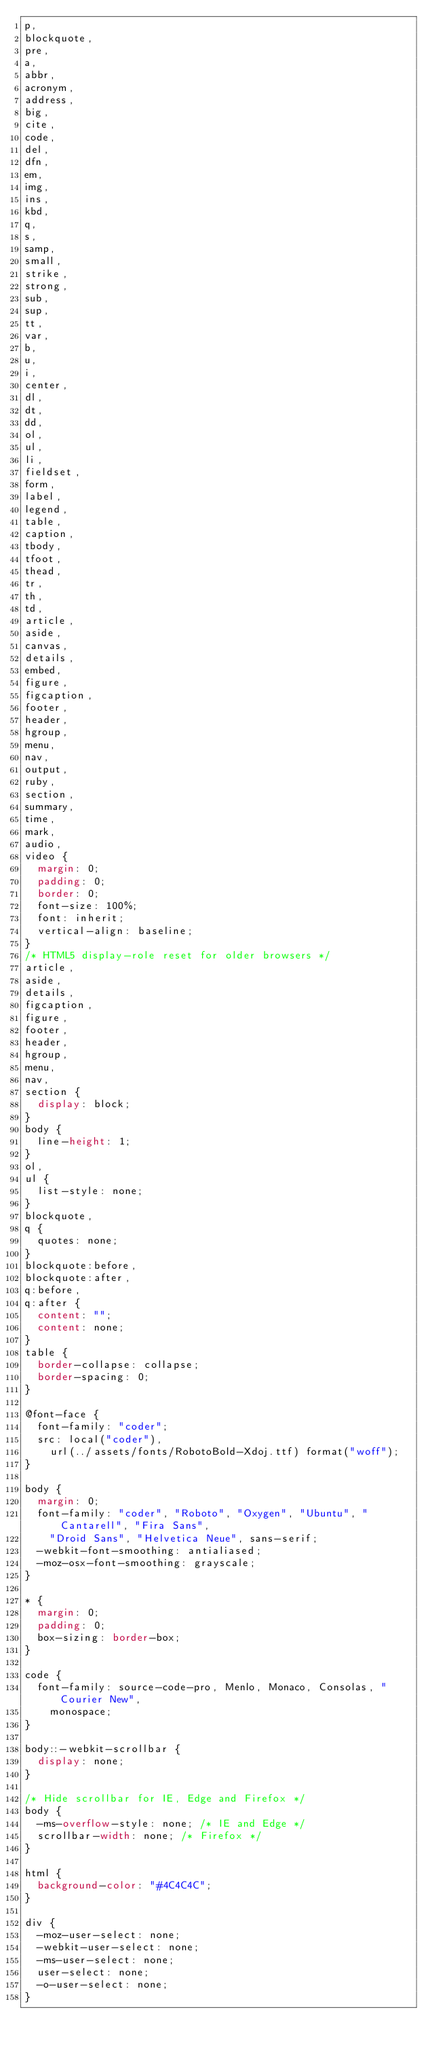<code> <loc_0><loc_0><loc_500><loc_500><_CSS_>p,
blockquote,
pre,
a,
abbr,
acronym,
address,
big,
cite,
code,
del,
dfn,
em,
img,
ins,
kbd,
q,
s,
samp,
small,
strike,
strong,
sub,
sup,
tt,
var,
b,
u,
i,
center,
dl,
dt,
dd,
ol,
ul,
li,
fieldset,
form,
label,
legend,
table,
caption,
tbody,
tfoot,
thead,
tr,
th,
td,
article,
aside,
canvas,
details,
embed,
figure,
figcaption,
footer,
header,
hgroup,
menu,
nav,
output,
ruby,
section,
summary,
time,
mark,
audio,
video {
  margin: 0;
  padding: 0;
  border: 0;
  font-size: 100%;
  font: inherit;
  vertical-align: baseline;
}
/* HTML5 display-role reset for older browsers */
article,
aside,
details,
figcaption,
figure,
footer,
header,
hgroup,
menu,
nav,
section {
  display: block;
}
body {
  line-height: 1;
}
ol,
ul {
  list-style: none;
}
blockquote,
q {
  quotes: none;
}
blockquote:before,
blockquote:after,
q:before,
q:after {
  content: "";
  content: none;
}
table {
  border-collapse: collapse;
  border-spacing: 0;
}

@font-face {
  font-family: "coder";
  src: local("coder"),
    url(../assets/fonts/RobotoBold-Xdoj.ttf) format("woff");
}

body {
  margin: 0;
  font-family: "coder", "Roboto", "Oxygen", "Ubuntu", "Cantarell", "Fira Sans",
    "Droid Sans", "Helvetica Neue", sans-serif;
  -webkit-font-smoothing: antialiased;
  -moz-osx-font-smoothing: grayscale;
}

* {
  margin: 0;
  padding: 0;
  box-sizing: border-box;
}

code {
  font-family: source-code-pro, Menlo, Monaco, Consolas, "Courier New",
    monospace;
}

body::-webkit-scrollbar {
  display: none;
}

/* Hide scrollbar for IE, Edge and Firefox */
body {
  -ms-overflow-style: none; /* IE and Edge */
  scrollbar-width: none; /* Firefox */
}

html {
  background-color: "#4C4C4C";
}

div {
  -moz-user-select: none;
  -webkit-user-select: none;
  -ms-user-select: none;
  user-select: none;
  -o-user-select: none;
}
</code> 